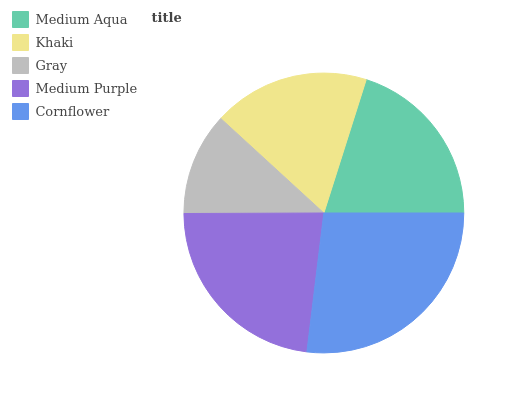Is Gray the minimum?
Answer yes or no. Yes. Is Cornflower the maximum?
Answer yes or no. Yes. Is Khaki the minimum?
Answer yes or no. No. Is Khaki the maximum?
Answer yes or no. No. Is Medium Aqua greater than Khaki?
Answer yes or no. Yes. Is Khaki less than Medium Aqua?
Answer yes or no. Yes. Is Khaki greater than Medium Aqua?
Answer yes or no. No. Is Medium Aqua less than Khaki?
Answer yes or no. No. Is Medium Aqua the high median?
Answer yes or no. Yes. Is Medium Aqua the low median?
Answer yes or no. Yes. Is Gray the high median?
Answer yes or no. No. Is Cornflower the low median?
Answer yes or no. No. 